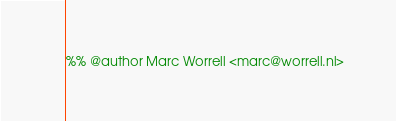Convert code to text. <code><loc_0><loc_0><loc_500><loc_500><_Erlang_>%% @author Marc Worrell <marc@worrell.nl></code> 